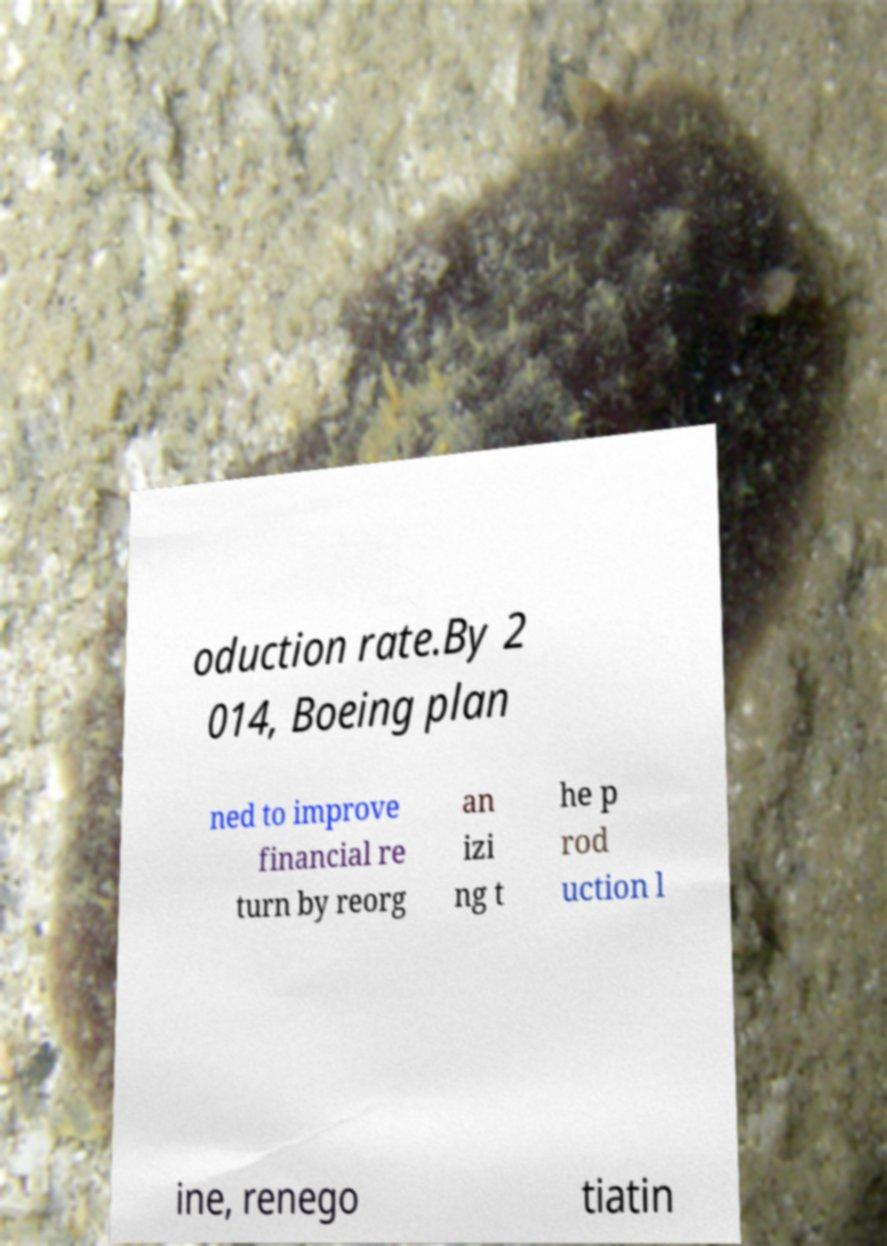Please read and relay the text visible in this image. What does it say? oduction rate.By 2 014, Boeing plan ned to improve financial re turn by reorg an izi ng t he p rod uction l ine, renego tiatin 